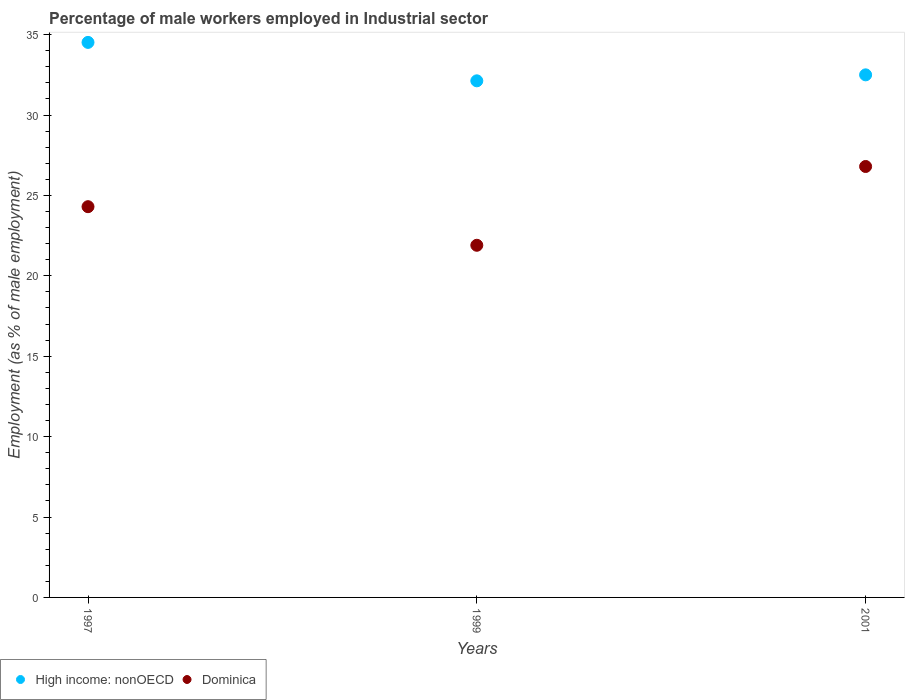How many different coloured dotlines are there?
Give a very brief answer. 2. Is the number of dotlines equal to the number of legend labels?
Ensure brevity in your answer.  Yes. What is the percentage of male workers employed in Industrial sector in Dominica in 2001?
Offer a terse response. 26.8. Across all years, what is the maximum percentage of male workers employed in Industrial sector in Dominica?
Keep it short and to the point. 26.8. Across all years, what is the minimum percentage of male workers employed in Industrial sector in High income: nonOECD?
Your answer should be compact. 32.13. In which year was the percentage of male workers employed in Industrial sector in Dominica maximum?
Your answer should be very brief. 2001. What is the total percentage of male workers employed in Industrial sector in High income: nonOECD in the graph?
Your answer should be very brief. 99.14. What is the difference between the percentage of male workers employed in Industrial sector in High income: nonOECD in 1997 and that in 2001?
Ensure brevity in your answer.  2.02. What is the difference between the percentage of male workers employed in Industrial sector in Dominica in 1997 and the percentage of male workers employed in Industrial sector in High income: nonOECD in 1999?
Ensure brevity in your answer.  -7.83. What is the average percentage of male workers employed in Industrial sector in High income: nonOECD per year?
Provide a succinct answer. 33.05. In the year 1999, what is the difference between the percentage of male workers employed in Industrial sector in Dominica and percentage of male workers employed in Industrial sector in High income: nonOECD?
Ensure brevity in your answer.  -10.23. In how many years, is the percentage of male workers employed in Industrial sector in Dominica greater than 22 %?
Ensure brevity in your answer.  2. What is the ratio of the percentage of male workers employed in Industrial sector in High income: nonOECD in 1997 to that in 1999?
Ensure brevity in your answer.  1.07. Is the percentage of male workers employed in Industrial sector in High income: nonOECD in 1997 less than that in 2001?
Offer a very short reply. No. What is the difference between the highest and the second highest percentage of male workers employed in Industrial sector in High income: nonOECD?
Provide a short and direct response. 2.02. What is the difference between the highest and the lowest percentage of male workers employed in Industrial sector in High income: nonOECD?
Your answer should be very brief. 2.39. In how many years, is the percentage of male workers employed in Industrial sector in High income: nonOECD greater than the average percentage of male workers employed in Industrial sector in High income: nonOECD taken over all years?
Give a very brief answer. 1. Is the percentage of male workers employed in Industrial sector in High income: nonOECD strictly greater than the percentage of male workers employed in Industrial sector in Dominica over the years?
Your answer should be very brief. Yes. How many dotlines are there?
Make the answer very short. 2. Does the graph contain any zero values?
Your answer should be very brief. No. Does the graph contain grids?
Offer a terse response. No. How are the legend labels stacked?
Your answer should be compact. Horizontal. What is the title of the graph?
Ensure brevity in your answer.  Percentage of male workers employed in Industrial sector. Does "Barbados" appear as one of the legend labels in the graph?
Your answer should be very brief. No. What is the label or title of the Y-axis?
Your answer should be compact. Employment (as % of male employment). What is the Employment (as % of male employment) in High income: nonOECD in 1997?
Your answer should be compact. 34.52. What is the Employment (as % of male employment) of Dominica in 1997?
Your answer should be very brief. 24.3. What is the Employment (as % of male employment) in High income: nonOECD in 1999?
Provide a short and direct response. 32.13. What is the Employment (as % of male employment) of Dominica in 1999?
Offer a terse response. 21.9. What is the Employment (as % of male employment) in High income: nonOECD in 2001?
Provide a succinct answer. 32.5. What is the Employment (as % of male employment) in Dominica in 2001?
Provide a short and direct response. 26.8. Across all years, what is the maximum Employment (as % of male employment) in High income: nonOECD?
Offer a very short reply. 34.52. Across all years, what is the maximum Employment (as % of male employment) in Dominica?
Ensure brevity in your answer.  26.8. Across all years, what is the minimum Employment (as % of male employment) of High income: nonOECD?
Give a very brief answer. 32.13. Across all years, what is the minimum Employment (as % of male employment) in Dominica?
Offer a very short reply. 21.9. What is the total Employment (as % of male employment) of High income: nonOECD in the graph?
Offer a very short reply. 99.14. What is the difference between the Employment (as % of male employment) in High income: nonOECD in 1997 and that in 1999?
Provide a succinct answer. 2.39. What is the difference between the Employment (as % of male employment) in High income: nonOECD in 1997 and that in 2001?
Provide a short and direct response. 2.02. What is the difference between the Employment (as % of male employment) of High income: nonOECD in 1999 and that in 2001?
Offer a terse response. -0.37. What is the difference between the Employment (as % of male employment) of High income: nonOECD in 1997 and the Employment (as % of male employment) of Dominica in 1999?
Give a very brief answer. 12.62. What is the difference between the Employment (as % of male employment) of High income: nonOECD in 1997 and the Employment (as % of male employment) of Dominica in 2001?
Your answer should be very brief. 7.72. What is the difference between the Employment (as % of male employment) of High income: nonOECD in 1999 and the Employment (as % of male employment) of Dominica in 2001?
Your answer should be compact. 5.33. What is the average Employment (as % of male employment) in High income: nonOECD per year?
Ensure brevity in your answer.  33.05. What is the average Employment (as % of male employment) of Dominica per year?
Your response must be concise. 24.33. In the year 1997, what is the difference between the Employment (as % of male employment) of High income: nonOECD and Employment (as % of male employment) of Dominica?
Your response must be concise. 10.22. In the year 1999, what is the difference between the Employment (as % of male employment) of High income: nonOECD and Employment (as % of male employment) of Dominica?
Make the answer very short. 10.23. In the year 2001, what is the difference between the Employment (as % of male employment) in High income: nonOECD and Employment (as % of male employment) in Dominica?
Keep it short and to the point. 5.7. What is the ratio of the Employment (as % of male employment) of High income: nonOECD in 1997 to that in 1999?
Provide a succinct answer. 1.07. What is the ratio of the Employment (as % of male employment) of Dominica in 1997 to that in 1999?
Give a very brief answer. 1.11. What is the ratio of the Employment (as % of male employment) of High income: nonOECD in 1997 to that in 2001?
Provide a short and direct response. 1.06. What is the ratio of the Employment (as % of male employment) in Dominica in 1997 to that in 2001?
Give a very brief answer. 0.91. What is the ratio of the Employment (as % of male employment) in Dominica in 1999 to that in 2001?
Provide a succinct answer. 0.82. What is the difference between the highest and the second highest Employment (as % of male employment) of High income: nonOECD?
Keep it short and to the point. 2.02. What is the difference between the highest and the lowest Employment (as % of male employment) in High income: nonOECD?
Your answer should be very brief. 2.39. What is the difference between the highest and the lowest Employment (as % of male employment) in Dominica?
Offer a very short reply. 4.9. 